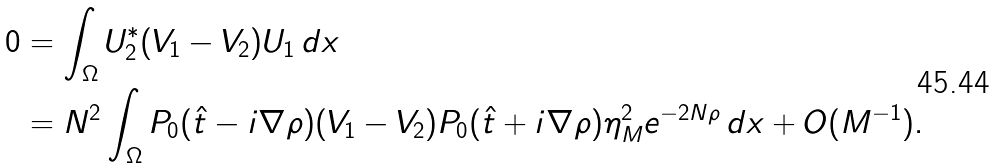Convert formula to latex. <formula><loc_0><loc_0><loc_500><loc_500>0 & = \int _ { \Omega } U _ { 2 } ^ { * } ( V _ { 1 } - V _ { 2 } ) U _ { 1 } \, d x \\ & = N ^ { 2 } \int _ { \Omega } P _ { 0 } ( \hat { t } - i \nabla \rho ) ( V _ { 1 } - V _ { 2 } ) P _ { 0 } ( \hat { t } + i \nabla \rho ) \eta _ { M } ^ { 2 } e ^ { - 2 N \rho } \, d x + O ( M ^ { - 1 } ) .</formula> 